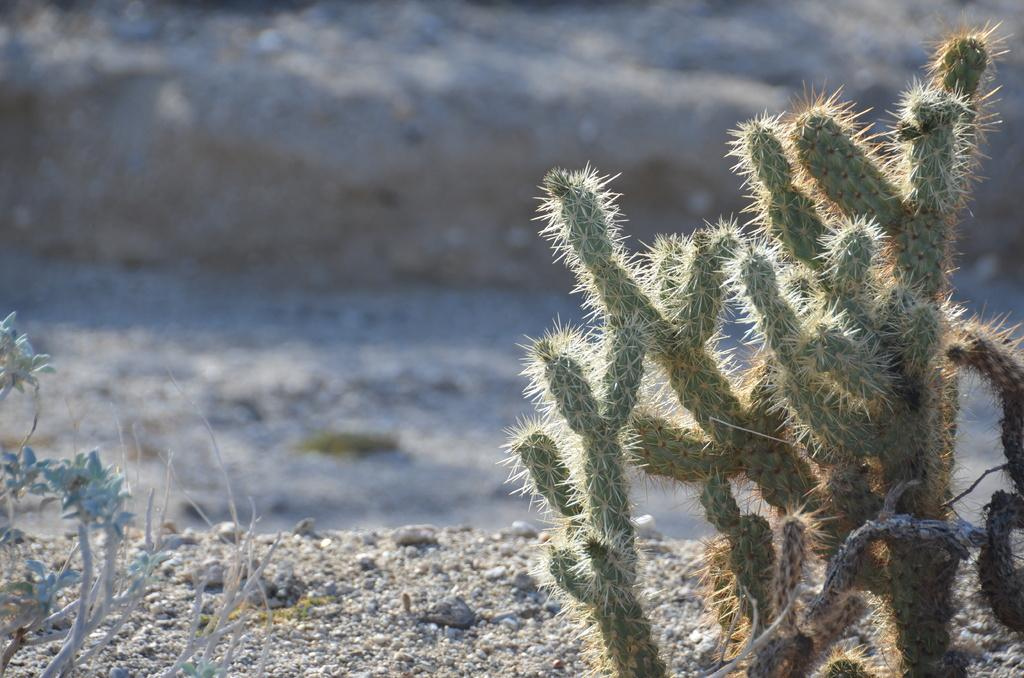What type of plants can be seen on the right side of the image? There are cactus plants on the right side of the image. What can be found on the ground in the image? There are stones on the ground in the image. What type of plants are visible on the left side of the image? There are plants visible on the left side of the image. How would you describe the background of the image? The background of the image is blurry. Can you tell me how many owls are perched on the cactus plants in the image? There are no owls present in the image; it features cactus plants and stones on the ground. What type of bird can be seen flying in the background of the image? There are no birds visible in the image; the background is blurry. 